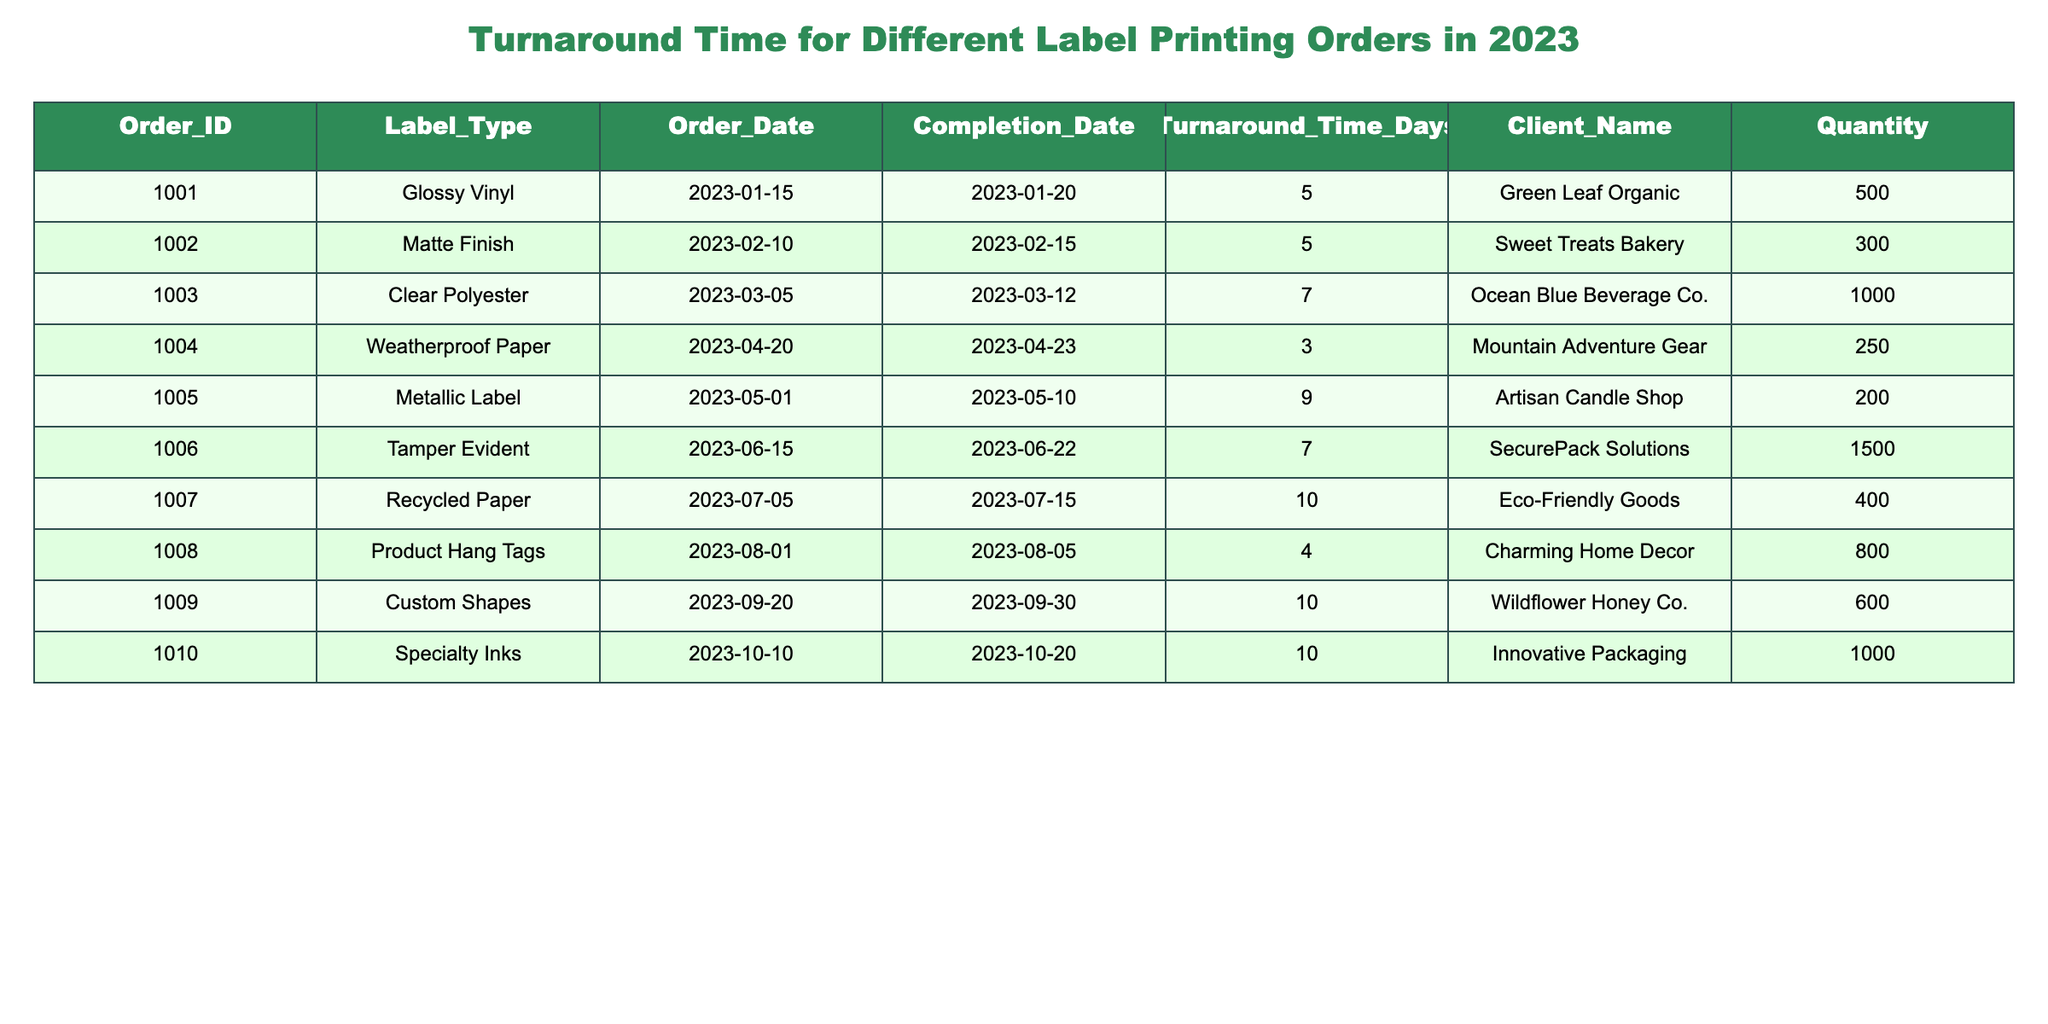What is the turnaround time for the order with ID 1003? Looking at the table, the turnaround time for order ID 1003 is specifically listed under the Turnaround_Time_Days column. The value for this order is 7 days.
Answer: 7 days Which label type has the longest turnaround time? To find this out, I need to compare the Turnaround_Time_Days values across all label types. The maximum value is 10 days, which appears for the label types Custom Shapes and Specialty Inks.
Answer: Custom Shapes and Specialty Inks How many orders had a turnaround time shorter than 5 days? By checking the Turnaround_Time_Days column, I can see that there are 3 orders with a turnaround time shorter than 5 days: Weatherproof Paper (3 days) and Product Hang Tags (4 days). Since there are no other entries with values below 5, the total is 2.
Answer: 2 What is the average turnaround time for all orders? First, adding the turnaround times together gives a total of 5 + 5 + 7 + 3 + 9 + 7 + 10 + 4 + 10 + 10 = 70 days. Next, dividing this sum by the number of orders (10) results in an average of 7 days.
Answer: 7 days Did any order take more than 8 days to complete? To determine this, I review the Turnaround_Time_Days column. The orders that fall into this category are Metallic Label (9 days), Recycled Paper (10 days), Custom Shapes (10 days), and Specialty Inks (10 days). Thus, the answer is yes.
Answer: Yes Which client had the shortest turnaround time and what was it? I need to review the Turnaround_Time_Days column and find the minimum value, which is 3 days for the order by Mountain Adventure Gear. Therefore, the client is Mountain Adventure Gear.
Answer: Mountain Adventure Gear, 3 days How many total labels were printed across all orders? To answer this, I sum the Quantity column values: 500 + 300 + 1000 + 250 + 200 + 1500 + 400 + 800 + 600 + 1000 = 5100.
Answer: 5100 What is the median turnaround time for these orders? To calculate the median, I first list the turnaround times: 3, 4, 5, 5, 7, 7, 9, 10, 10, 10. As there are 10 values, the median will be the average of the 5th and 6th values. The average of 7 and 7 is 7.
Answer: 7 